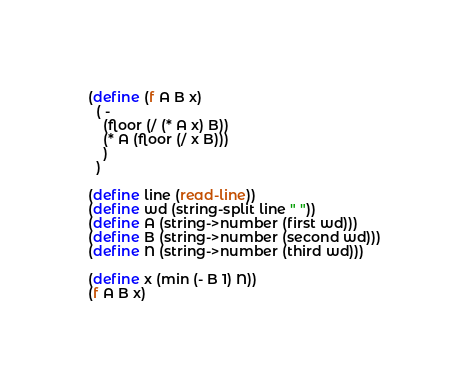<code> <loc_0><loc_0><loc_500><loc_500><_Scheme_>(define (f A B x) 
  ( - 
    (floor (/ (* A x) B))
    (* A (floor (/ x B)))
    )
  )

(define line (read-line))
(define wd (string-split line " "))
(define A (string->number (first wd)))
(define B (string->number (second wd)))
(define N (string->number (third wd)))

(define x (min (- B 1) N))
(f A B x)
</code> 